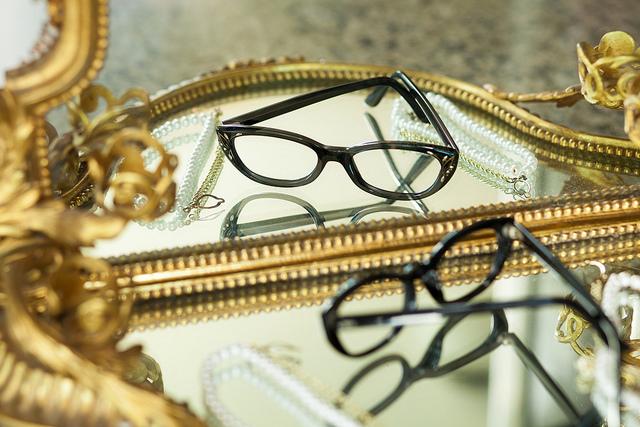Are the glasses in front of anything?
Answer briefly. Mirror. Are those glasses real?
Give a very brief answer. Yes. What color are the glasses?
Give a very brief answer. Black. 